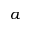Convert formula to latex. <formula><loc_0><loc_0><loc_500><loc_500>a</formula> 